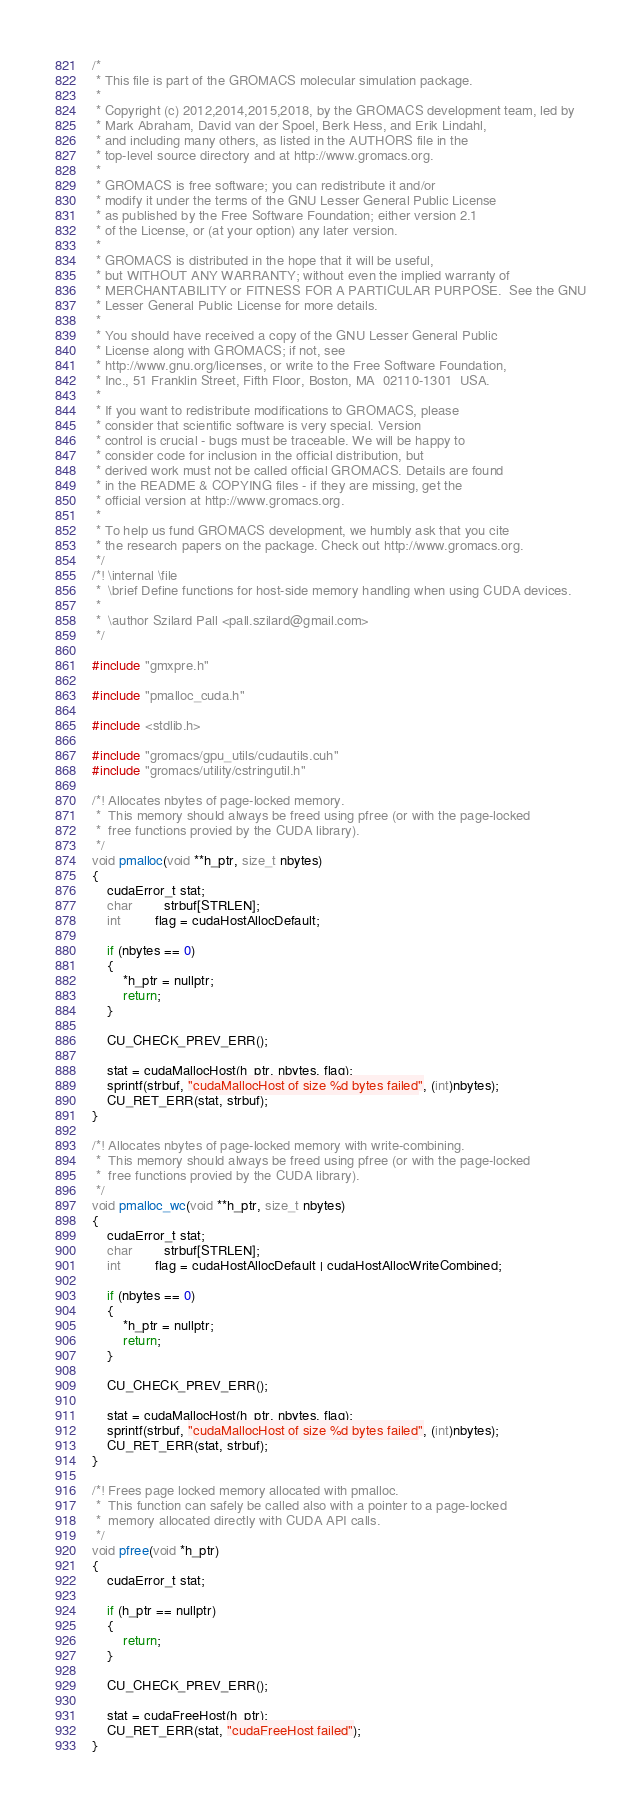<code> <loc_0><loc_0><loc_500><loc_500><_Cuda_>/*
 * This file is part of the GROMACS molecular simulation package.
 *
 * Copyright (c) 2012,2014,2015,2018, by the GROMACS development team, led by
 * Mark Abraham, David van der Spoel, Berk Hess, and Erik Lindahl,
 * and including many others, as listed in the AUTHORS file in the
 * top-level source directory and at http://www.gromacs.org.
 *
 * GROMACS is free software; you can redistribute it and/or
 * modify it under the terms of the GNU Lesser General Public License
 * as published by the Free Software Foundation; either version 2.1
 * of the License, or (at your option) any later version.
 *
 * GROMACS is distributed in the hope that it will be useful,
 * but WITHOUT ANY WARRANTY; without even the implied warranty of
 * MERCHANTABILITY or FITNESS FOR A PARTICULAR PURPOSE.  See the GNU
 * Lesser General Public License for more details.
 *
 * You should have received a copy of the GNU Lesser General Public
 * License along with GROMACS; if not, see
 * http://www.gnu.org/licenses, or write to the Free Software Foundation,
 * Inc., 51 Franklin Street, Fifth Floor, Boston, MA  02110-1301  USA.
 *
 * If you want to redistribute modifications to GROMACS, please
 * consider that scientific software is very special. Version
 * control is crucial - bugs must be traceable. We will be happy to
 * consider code for inclusion in the official distribution, but
 * derived work must not be called official GROMACS. Details are found
 * in the README & COPYING files - if they are missing, get the
 * official version at http://www.gromacs.org.
 *
 * To help us fund GROMACS development, we humbly ask that you cite
 * the research papers on the package. Check out http://www.gromacs.org.
 */
/*! \internal \file
 *  \brief Define functions for host-side memory handling when using CUDA devices.
 *
 *  \author Szilard Pall <pall.szilard@gmail.com>
 */

#include "gmxpre.h"

#include "pmalloc_cuda.h"

#include <stdlib.h>

#include "gromacs/gpu_utils/cudautils.cuh"
#include "gromacs/utility/cstringutil.h"

/*! Allocates nbytes of page-locked memory.
 *  This memory should always be freed using pfree (or with the page-locked
 *  free functions provied by the CUDA library).
 */
void pmalloc(void **h_ptr, size_t nbytes)
{
    cudaError_t stat;
    char        strbuf[STRLEN];
    int         flag = cudaHostAllocDefault;

    if (nbytes == 0)
    {
        *h_ptr = nullptr;
        return;
    }

    CU_CHECK_PREV_ERR();

    stat = cudaMallocHost(h_ptr, nbytes, flag);
    sprintf(strbuf, "cudaMallocHost of size %d bytes failed", (int)nbytes);
    CU_RET_ERR(stat, strbuf);
}

/*! Allocates nbytes of page-locked memory with write-combining.
 *  This memory should always be freed using pfree (or with the page-locked
 *  free functions provied by the CUDA library).
 */
void pmalloc_wc(void **h_ptr, size_t nbytes)
{
    cudaError_t stat;
    char        strbuf[STRLEN];
    int         flag = cudaHostAllocDefault | cudaHostAllocWriteCombined;

    if (nbytes == 0)
    {
        *h_ptr = nullptr;
        return;
    }

    CU_CHECK_PREV_ERR();

    stat = cudaMallocHost(h_ptr, nbytes, flag);
    sprintf(strbuf, "cudaMallocHost of size %d bytes failed", (int)nbytes);
    CU_RET_ERR(stat, strbuf);
}

/*! Frees page locked memory allocated with pmalloc.
 *  This function can safely be called also with a pointer to a page-locked
 *  memory allocated directly with CUDA API calls.
 */
void pfree(void *h_ptr)
{
    cudaError_t stat;

    if (h_ptr == nullptr)
    {
        return;
    }

    CU_CHECK_PREV_ERR();

    stat = cudaFreeHost(h_ptr);
    CU_RET_ERR(stat, "cudaFreeHost failed");
}
</code> 